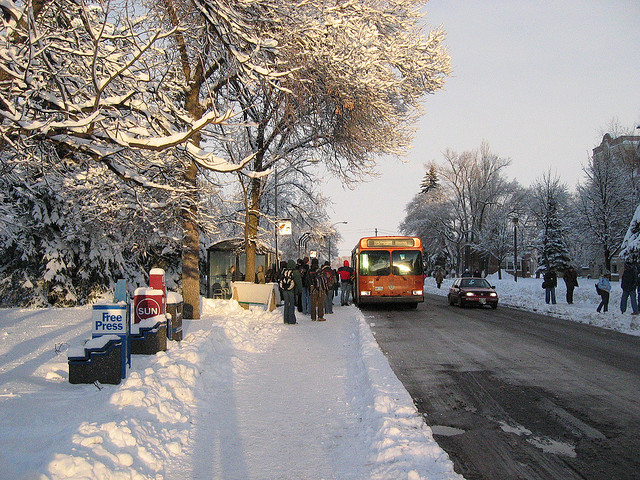Please identify all text content in this image. Free Press SUN 